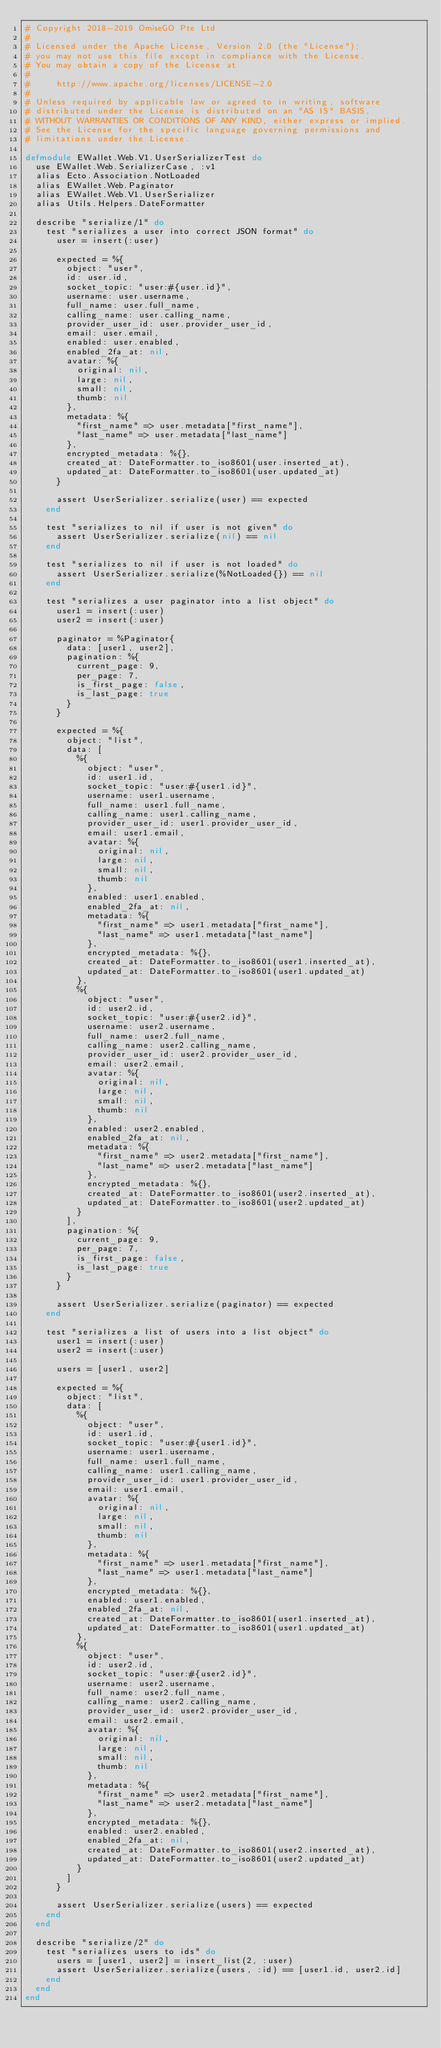Convert code to text. <code><loc_0><loc_0><loc_500><loc_500><_Elixir_># Copyright 2018-2019 OmiseGO Pte Ltd
#
# Licensed under the Apache License, Version 2.0 (the "License");
# you may not use this file except in compliance with the License.
# You may obtain a copy of the License at
#
#     http://www.apache.org/licenses/LICENSE-2.0
#
# Unless required by applicable law or agreed to in writing, software
# distributed under the License is distributed on an "AS IS" BASIS,
# WITHOUT WARRANTIES OR CONDITIONS OF ANY KIND, either express or implied.
# See the License for the specific language governing permissions and
# limitations under the License.

defmodule EWallet.Web.V1.UserSerializerTest do
  use EWallet.Web.SerializerCase, :v1
  alias Ecto.Association.NotLoaded
  alias EWallet.Web.Paginator
  alias EWallet.Web.V1.UserSerializer
  alias Utils.Helpers.DateFormatter

  describe "serialize/1" do
    test "serializes a user into correct JSON format" do
      user = insert(:user)

      expected = %{
        object: "user",
        id: user.id,
        socket_topic: "user:#{user.id}",
        username: user.username,
        full_name: user.full_name,
        calling_name: user.calling_name,
        provider_user_id: user.provider_user_id,
        email: user.email,
        enabled: user.enabled,
        enabled_2fa_at: nil,
        avatar: %{
          original: nil,
          large: nil,
          small: nil,
          thumb: nil
        },
        metadata: %{
          "first_name" => user.metadata["first_name"],
          "last_name" => user.metadata["last_name"]
        },
        encrypted_metadata: %{},
        created_at: DateFormatter.to_iso8601(user.inserted_at),
        updated_at: DateFormatter.to_iso8601(user.updated_at)
      }

      assert UserSerializer.serialize(user) == expected
    end

    test "serializes to nil if user is not given" do
      assert UserSerializer.serialize(nil) == nil
    end

    test "serializes to nil if user is not loaded" do
      assert UserSerializer.serialize(%NotLoaded{}) == nil
    end

    test "serializes a user paginator into a list object" do
      user1 = insert(:user)
      user2 = insert(:user)

      paginator = %Paginator{
        data: [user1, user2],
        pagination: %{
          current_page: 9,
          per_page: 7,
          is_first_page: false,
          is_last_page: true
        }
      }

      expected = %{
        object: "list",
        data: [
          %{
            object: "user",
            id: user1.id,
            socket_topic: "user:#{user1.id}",
            username: user1.username,
            full_name: user1.full_name,
            calling_name: user1.calling_name,
            provider_user_id: user1.provider_user_id,
            email: user1.email,
            avatar: %{
              original: nil,
              large: nil,
              small: nil,
              thumb: nil
            },
            enabled: user1.enabled,
            enabled_2fa_at: nil,
            metadata: %{
              "first_name" => user1.metadata["first_name"],
              "last_name" => user1.metadata["last_name"]
            },
            encrypted_metadata: %{},
            created_at: DateFormatter.to_iso8601(user1.inserted_at),
            updated_at: DateFormatter.to_iso8601(user1.updated_at)
          },
          %{
            object: "user",
            id: user2.id,
            socket_topic: "user:#{user2.id}",
            username: user2.username,
            full_name: user2.full_name,
            calling_name: user2.calling_name,
            provider_user_id: user2.provider_user_id,
            email: user2.email,
            avatar: %{
              original: nil,
              large: nil,
              small: nil,
              thumb: nil
            },
            enabled: user2.enabled,
            enabled_2fa_at: nil,
            metadata: %{
              "first_name" => user2.metadata["first_name"],
              "last_name" => user2.metadata["last_name"]
            },
            encrypted_metadata: %{},
            created_at: DateFormatter.to_iso8601(user2.inserted_at),
            updated_at: DateFormatter.to_iso8601(user2.updated_at)
          }
        ],
        pagination: %{
          current_page: 9,
          per_page: 7,
          is_first_page: false,
          is_last_page: true
        }
      }

      assert UserSerializer.serialize(paginator) == expected
    end

    test "serializes a list of users into a list object" do
      user1 = insert(:user)
      user2 = insert(:user)

      users = [user1, user2]

      expected = %{
        object: "list",
        data: [
          %{
            object: "user",
            id: user1.id,
            socket_topic: "user:#{user1.id}",
            username: user1.username,
            full_name: user1.full_name,
            calling_name: user1.calling_name,
            provider_user_id: user1.provider_user_id,
            email: user1.email,
            avatar: %{
              original: nil,
              large: nil,
              small: nil,
              thumb: nil
            },
            metadata: %{
              "first_name" => user1.metadata["first_name"],
              "last_name" => user1.metadata["last_name"]
            },
            encrypted_metadata: %{},
            enabled: user1.enabled,
            enabled_2fa_at: nil,
            created_at: DateFormatter.to_iso8601(user1.inserted_at),
            updated_at: DateFormatter.to_iso8601(user1.updated_at)
          },
          %{
            object: "user",
            id: user2.id,
            socket_topic: "user:#{user2.id}",
            username: user2.username,
            full_name: user2.full_name,
            calling_name: user2.calling_name,
            provider_user_id: user2.provider_user_id,
            email: user2.email,
            avatar: %{
              original: nil,
              large: nil,
              small: nil,
              thumb: nil
            },
            metadata: %{
              "first_name" => user2.metadata["first_name"],
              "last_name" => user2.metadata["last_name"]
            },
            encrypted_metadata: %{},
            enabled: user2.enabled,
            enabled_2fa_at: nil,
            created_at: DateFormatter.to_iso8601(user2.inserted_at),
            updated_at: DateFormatter.to_iso8601(user2.updated_at)
          }
        ]
      }

      assert UserSerializer.serialize(users) == expected
    end
  end

  describe "serialize/2" do
    test "serializes users to ids" do
      users = [user1, user2] = insert_list(2, :user)
      assert UserSerializer.serialize(users, :id) == [user1.id, user2.id]
    end
  end
end
</code> 